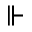Convert formula to latex. <formula><loc_0><loc_0><loc_500><loc_500>\ V d a s h</formula> 